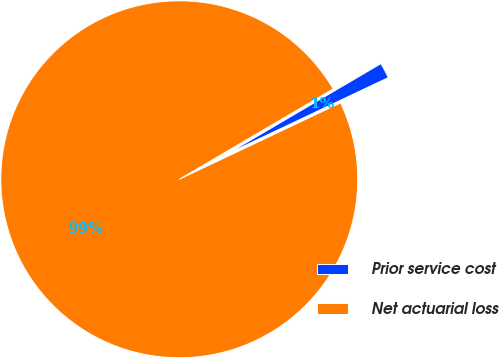Convert chart. <chart><loc_0><loc_0><loc_500><loc_500><pie_chart><fcel>Prior service cost<fcel>Net actuarial loss<nl><fcel>1.41%<fcel>98.59%<nl></chart> 